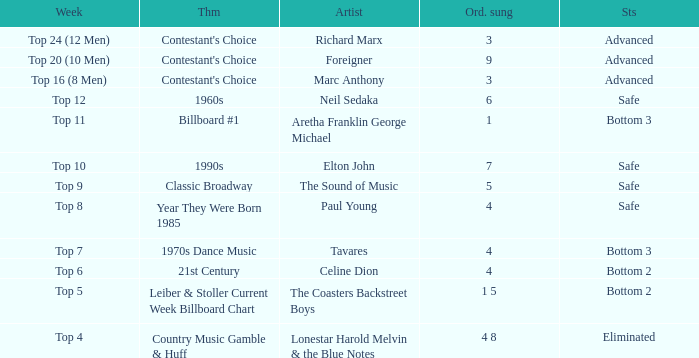What was the theme for the Top 11 week? Billboard #1. 